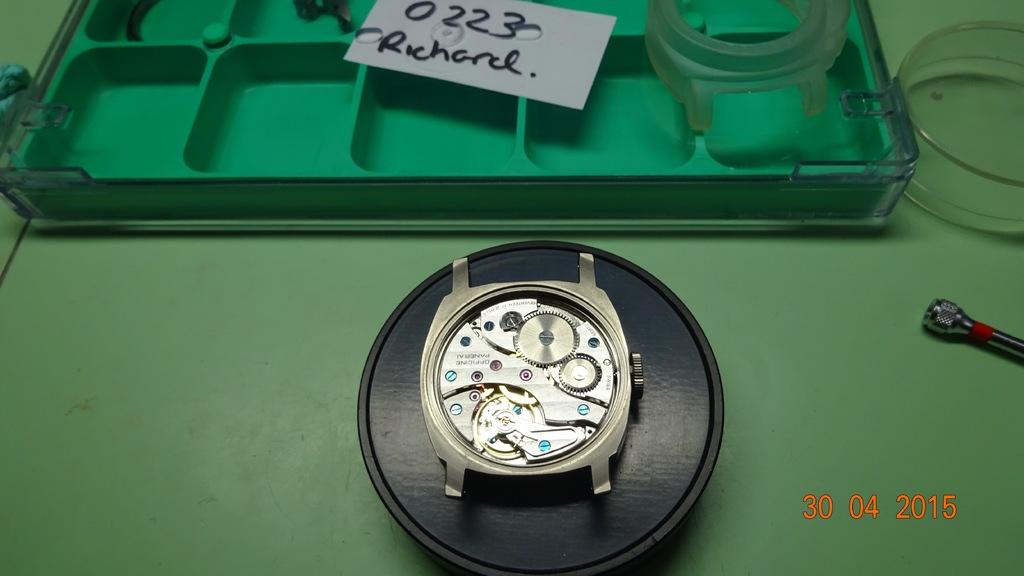<image>
Share a concise interpretation of the image provided. Back of a wristwatch near a white sign that says Richard on it. 